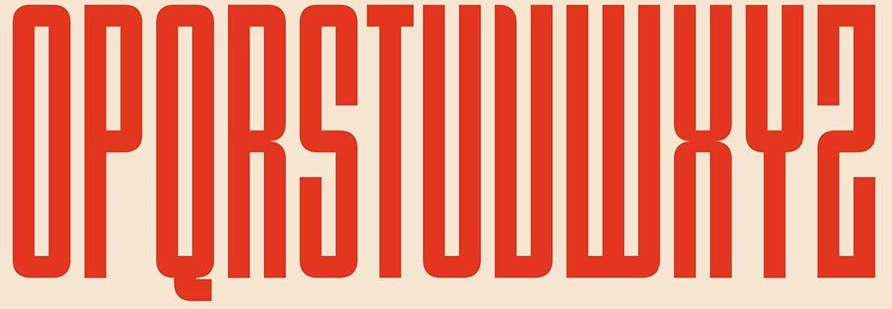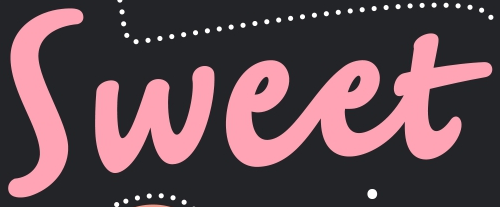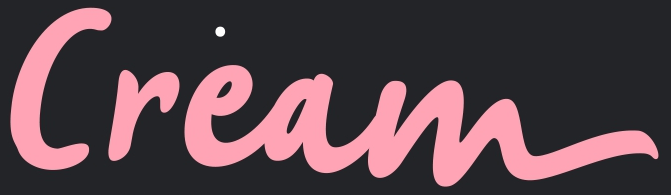Read the text from these images in sequence, separated by a semicolon. OPQRSTUVWXYZ; Sweet; Cream 